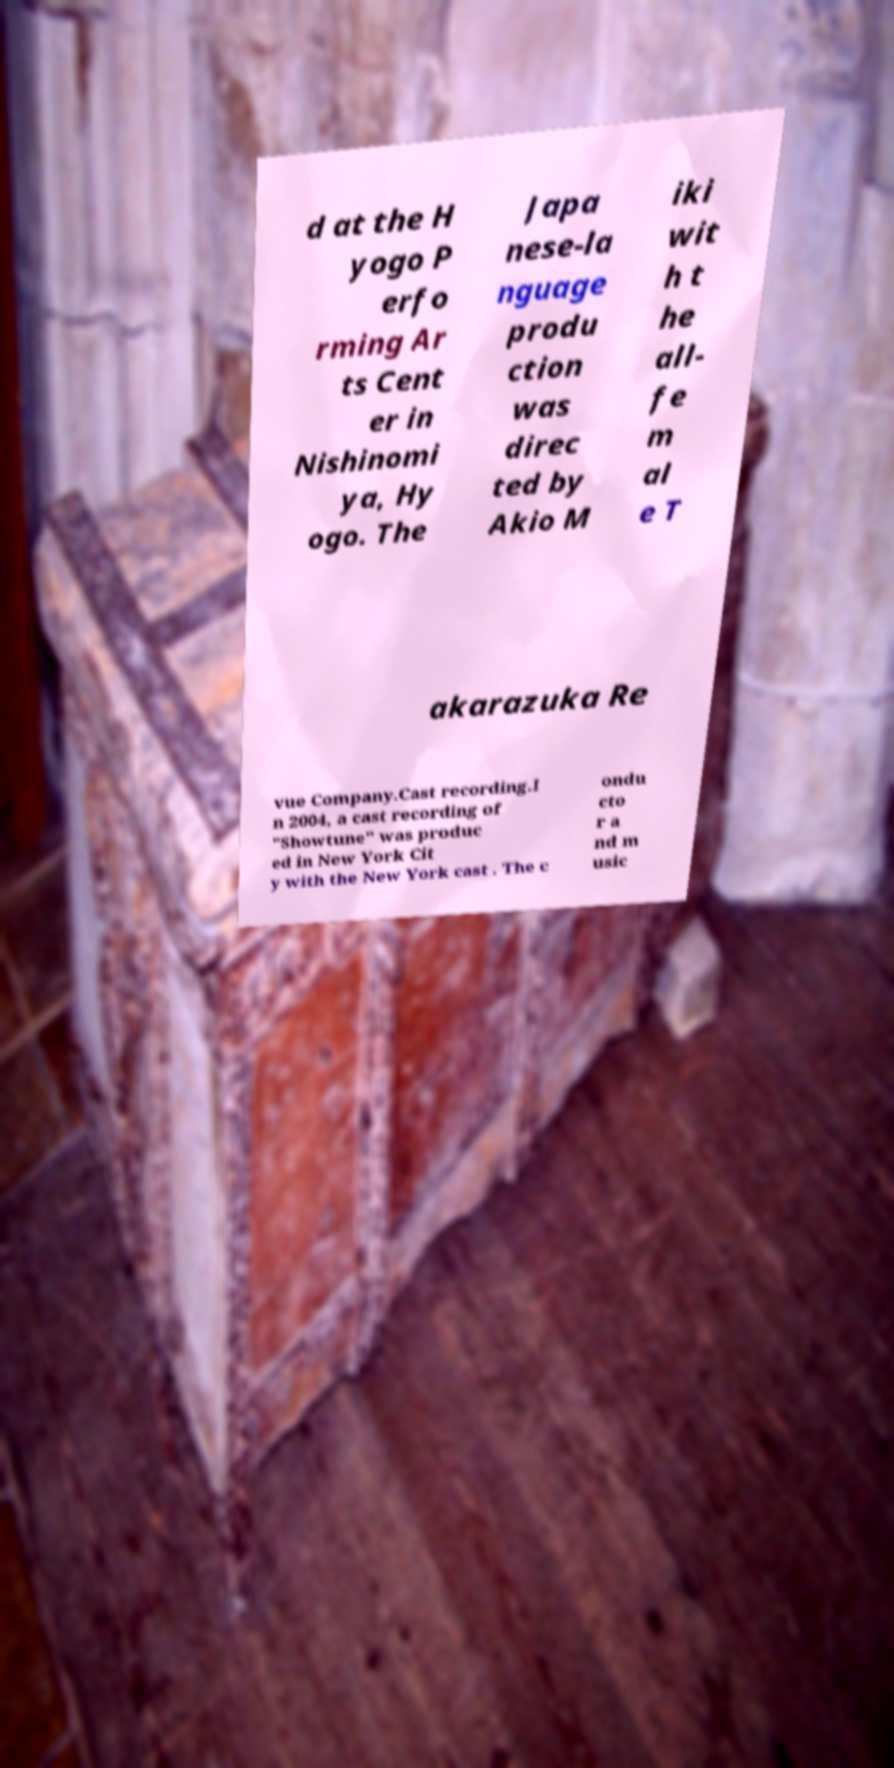There's text embedded in this image that I need extracted. Can you transcribe it verbatim? d at the H yogo P erfo rming Ar ts Cent er in Nishinomi ya, Hy ogo. The Japa nese-la nguage produ ction was direc ted by Akio M iki wit h t he all- fe m al e T akarazuka Re vue Company.Cast recording.I n 2004, a cast recording of "Showtune" was produc ed in New York Cit y with the New York cast . The c ondu cto r a nd m usic 